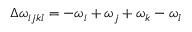Convert formula to latex. <formula><loc_0><loc_0><loc_500><loc_500>\Delta \omega _ { i j k l } = - \omega _ { i } + \omega _ { j } + \omega _ { k } - \omega _ { l }</formula> 